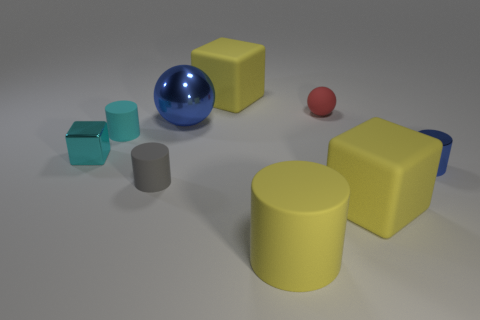Is there anything else that is the same material as the tiny blue thing?
Provide a succinct answer. Yes. Is the shiny cube the same color as the big cylinder?
Provide a succinct answer. No. What is the size of the matte cube that is in front of the cyan cylinder?
Offer a terse response. Large. There is a matte block that is right of the small red matte object; does it have the same color as the sphere that is to the left of the matte ball?
Provide a succinct answer. No. How many other objects are there of the same shape as the cyan shiny object?
Your answer should be compact. 2. Are there the same number of matte spheres in front of the shiny cylinder and big blue metallic balls that are behind the blue metal ball?
Offer a very short reply. Yes. Are the cube left of the gray matte thing and the small thing that is right of the rubber sphere made of the same material?
Provide a succinct answer. Yes. How many other objects are there of the same size as the blue sphere?
Your answer should be compact. 3. What number of things are shiny spheres or cylinders that are in front of the shiny block?
Ensure brevity in your answer.  4. Is the number of small cyan blocks to the right of the large blue metal thing the same as the number of green cylinders?
Offer a very short reply. Yes. 